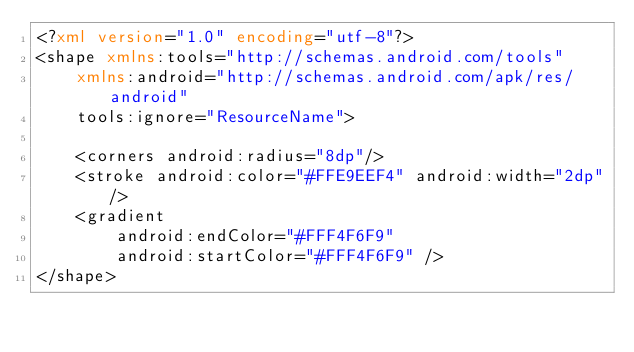Convert code to text. <code><loc_0><loc_0><loc_500><loc_500><_XML_><?xml version="1.0" encoding="utf-8"?>
<shape xmlns:tools="http://schemas.android.com/tools"
    xmlns:android="http://schemas.android.com/apk/res/android"
    tools:ignore="ResourceName">

    <corners android:radius="8dp"/>
    <stroke android:color="#FFE9EEF4" android:width="2dp"/>
    <gradient
        android:endColor="#FFF4F6F9"
        android:startColor="#FFF4F6F9" />
</shape></code> 